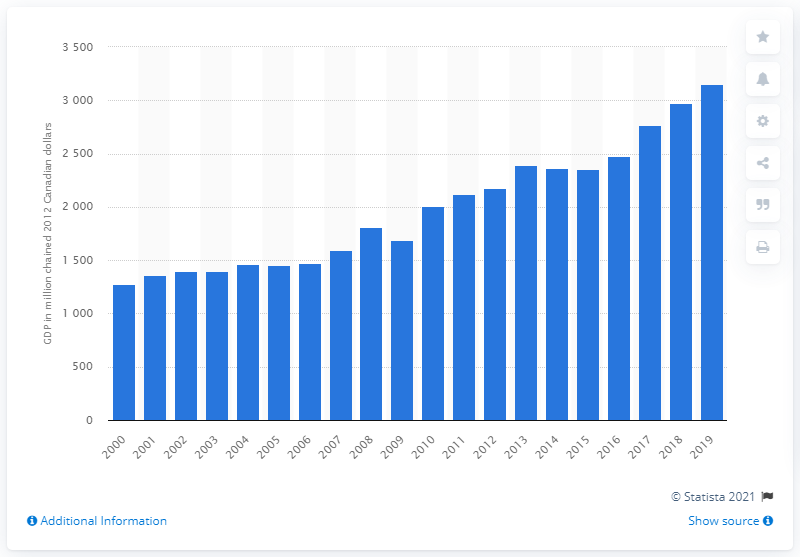Mention a couple of crucial points in this snapshot. In 2012, Nunavut's GDP was 3156.4 million Canadian dollars. 